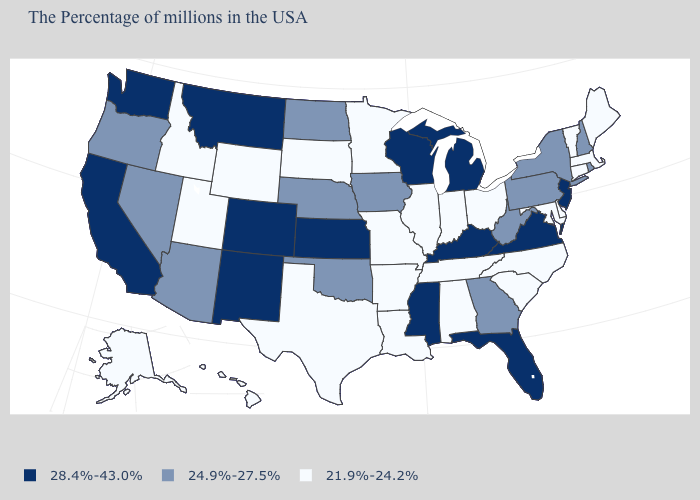What is the value of Alabama?
Give a very brief answer. 21.9%-24.2%. Which states have the highest value in the USA?
Be succinct. New Jersey, Virginia, Florida, Michigan, Kentucky, Wisconsin, Mississippi, Kansas, Colorado, New Mexico, Montana, California, Washington. What is the value of West Virginia?
Be succinct. 24.9%-27.5%. What is the value of Pennsylvania?
Keep it brief. 24.9%-27.5%. Among the states that border Utah , which have the highest value?
Be succinct. Colorado, New Mexico. What is the value of New Hampshire?
Give a very brief answer. 24.9%-27.5%. Is the legend a continuous bar?
Quick response, please. No. What is the value of Georgia?
Quick response, please. 24.9%-27.5%. How many symbols are there in the legend?
Write a very short answer. 3. Among the states that border South Dakota , which have the lowest value?
Concise answer only. Minnesota, Wyoming. Does Kansas have the lowest value in the MidWest?
Short answer required. No. Name the states that have a value in the range 24.9%-27.5%?
Quick response, please. Rhode Island, New Hampshire, New York, Pennsylvania, West Virginia, Georgia, Iowa, Nebraska, Oklahoma, North Dakota, Arizona, Nevada, Oregon. Name the states that have a value in the range 24.9%-27.5%?
Concise answer only. Rhode Island, New Hampshire, New York, Pennsylvania, West Virginia, Georgia, Iowa, Nebraska, Oklahoma, North Dakota, Arizona, Nevada, Oregon. Name the states that have a value in the range 21.9%-24.2%?
Answer briefly. Maine, Massachusetts, Vermont, Connecticut, Delaware, Maryland, North Carolina, South Carolina, Ohio, Indiana, Alabama, Tennessee, Illinois, Louisiana, Missouri, Arkansas, Minnesota, Texas, South Dakota, Wyoming, Utah, Idaho, Alaska, Hawaii. Among the states that border New York , which have the lowest value?
Short answer required. Massachusetts, Vermont, Connecticut. 